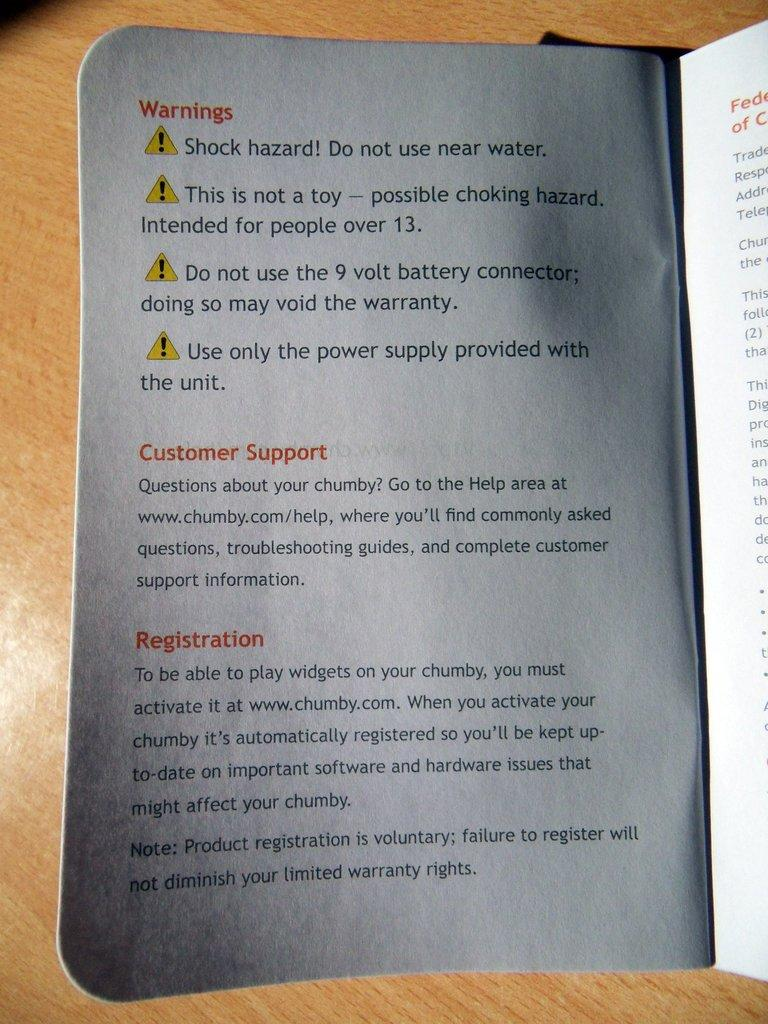Provide a one-sentence caption for the provided image. an instruction booklet open to a page about WARNINGS. 